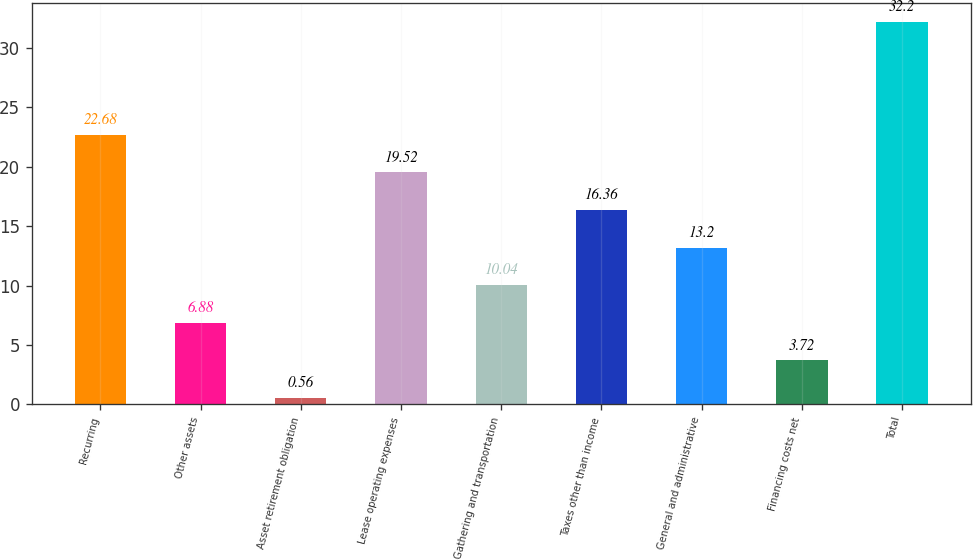Convert chart. <chart><loc_0><loc_0><loc_500><loc_500><bar_chart><fcel>Recurring<fcel>Other assets<fcel>Asset retirement obligation<fcel>Lease operating expenses<fcel>Gathering and transportation<fcel>Taxes other than income<fcel>General and administrative<fcel>Financing costs net<fcel>Total<nl><fcel>22.68<fcel>6.88<fcel>0.56<fcel>19.52<fcel>10.04<fcel>16.36<fcel>13.2<fcel>3.72<fcel>32.2<nl></chart> 